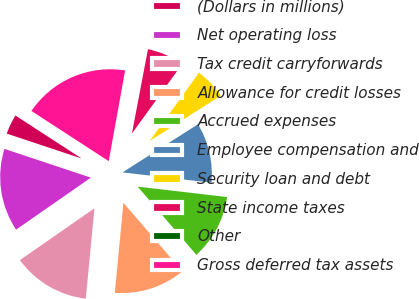Convert chart to OTSL. <chart><loc_0><loc_0><loc_500><loc_500><pie_chart><fcel>(Dollars in millions)<fcel>Net operating loss<fcel>Tax credit carryforwards<fcel>Allowance for credit losses<fcel>Accrued expenses<fcel>Employee compensation and<fcel>Security loan and debt<fcel>State income taxes<fcel>Other<fcel>Gross deferred tax assets<nl><fcel>4.05%<fcel>14.78%<fcel>13.81%<fcel>12.83%<fcel>11.85%<fcel>10.88%<fcel>6.0%<fcel>6.97%<fcel>0.14%<fcel>18.69%<nl></chart> 